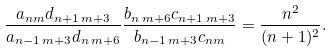<formula> <loc_0><loc_0><loc_500><loc_500>\frac { a _ { n m } d _ { n + 1 \, m + 3 } } { a _ { n - 1 \, m + 3 } d _ { n \, m + 6 } } \frac { b _ { n \, m + 6 } c _ { n + 1 \, m + 3 } } { b _ { n - 1 \, m + 3 } c _ { n m } } = \frac { n ^ { 2 } } { ( n + 1 ) ^ { 2 } } .</formula> 